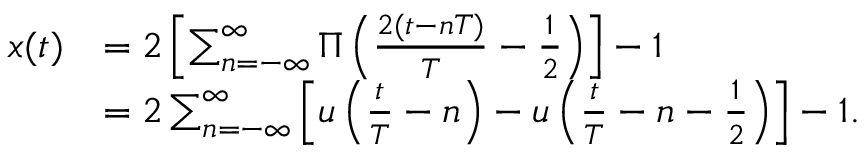Convert formula to latex. <formula><loc_0><loc_0><loc_500><loc_500>{ \begin{array} { r l } { x ( t ) } & { = 2 \left [ \sum _ { n = - \infty } ^ { \infty } \Pi \left ( { \frac { 2 ( t - n T ) } { T } } - { \frac { 1 } { 2 } } \right ) \right ] - 1 } \\ & { = 2 \sum _ { n = - \infty } ^ { \infty } \left [ u \left ( { \frac { t } { T } } - n \right ) - u \left ( { \frac { t } { T } } - n - { \frac { 1 } { 2 } } \right ) \right ] - 1 . } \end{array} }</formula> 